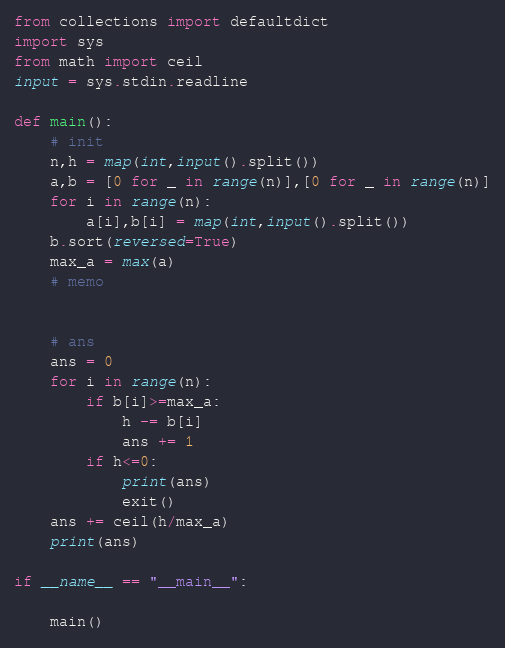Convert code to text. <code><loc_0><loc_0><loc_500><loc_500><_Python_>from collections import defaultdict
import sys
from math import ceil
input = sys.stdin.readline

def main():
    # init
    n,h = map(int,input().split())
    a,b = [0 for _ in range(n)],[0 for _ in range(n)]
    for i in range(n):
        a[i],b[i] = map(int,input().split())
    b.sort(reversed=True)
    max_a = max(a)
    # memo
    

    # ans
    ans = 0
    for i in range(n):
        if b[i]>=max_a:
            h -= b[i]
            ans += 1
        if h<=0:
            print(ans)
            exit()
    ans += ceil(h/max_a)
    print(ans)
    
if __name__ == "__main__":

    main()</code> 